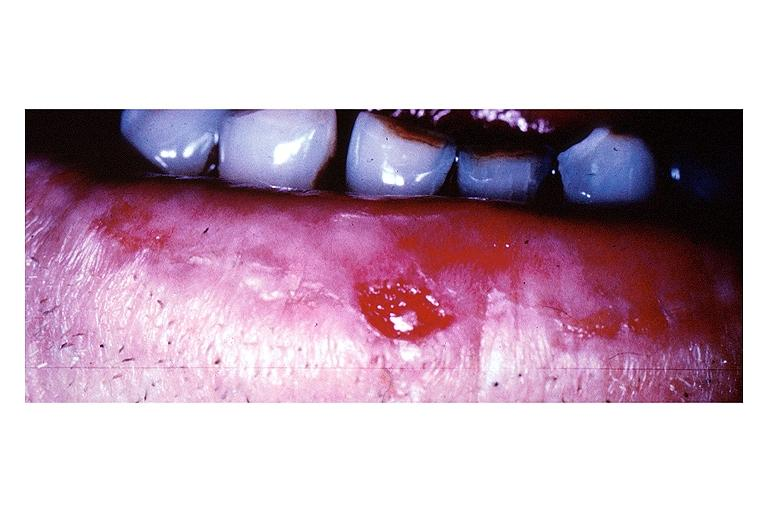what is present?
Answer the question using a single word or phrase. Oral 